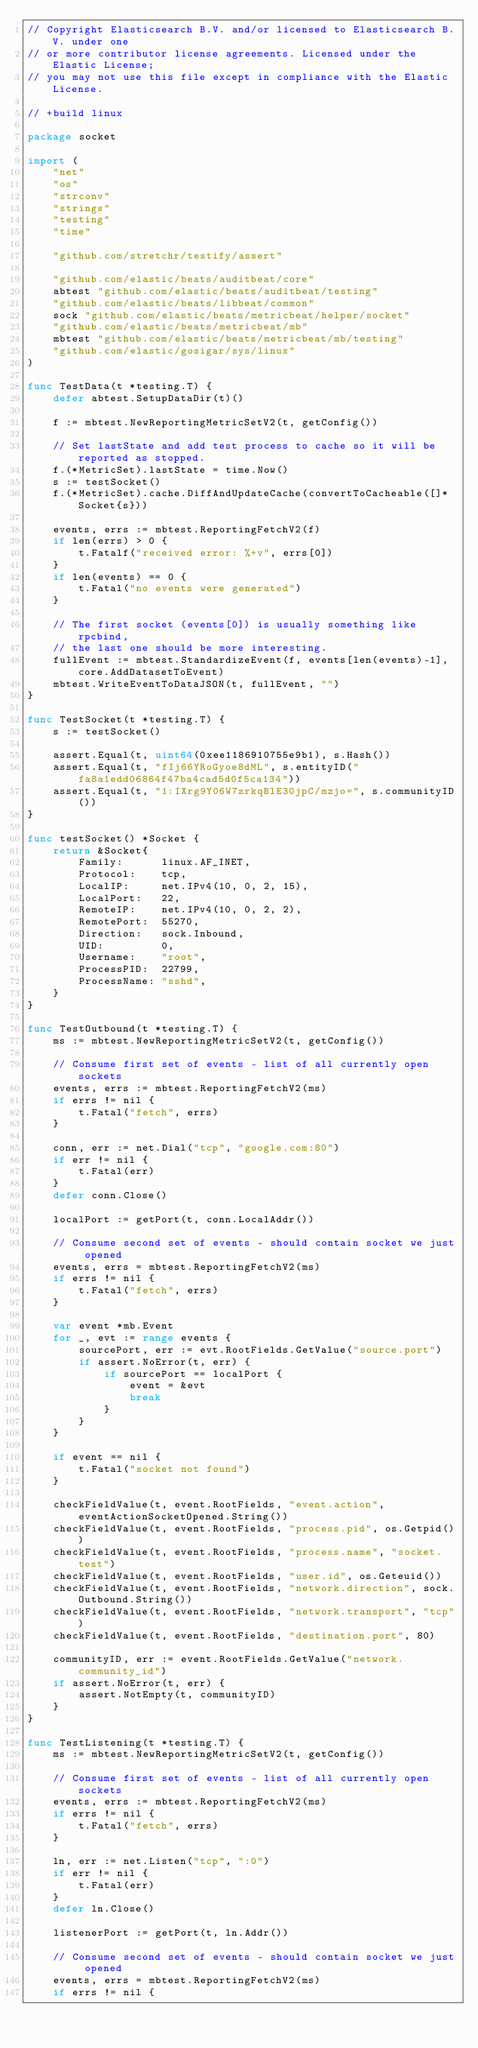<code> <loc_0><loc_0><loc_500><loc_500><_Go_>// Copyright Elasticsearch B.V. and/or licensed to Elasticsearch B.V. under one
// or more contributor license agreements. Licensed under the Elastic License;
// you may not use this file except in compliance with the Elastic License.

// +build linux

package socket

import (
	"net"
	"os"
	"strconv"
	"strings"
	"testing"
	"time"

	"github.com/stretchr/testify/assert"

	"github.com/elastic/beats/auditbeat/core"
	abtest "github.com/elastic/beats/auditbeat/testing"
	"github.com/elastic/beats/libbeat/common"
	sock "github.com/elastic/beats/metricbeat/helper/socket"
	"github.com/elastic/beats/metricbeat/mb"
	mbtest "github.com/elastic/beats/metricbeat/mb/testing"
	"github.com/elastic/gosigar/sys/linux"
)

func TestData(t *testing.T) {
	defer abtest.SetupDataDir(t)()

	f := mbtest.NewReportingMetricSetV2(t, getConfig())

	// Set lastState and add test process to cache so it will be reported as stopped.
	f.(*MetricSet).lastState = time.Now()
	s := testSocket()
	f.(*MetricSet).cache.DiffAndUpdateCache(convertToCacheable([]*Socket{s}))

	events, errs := mbtest.ReportingFetchV2(f)
	if len(errs) > 0 {
		t.Fatalf("received error: %+v", errs[0])
	}
	if len(events) == 0 {
		t.Fatal("no events were generated")
	}

	// The first socket (events[0]) is usually something like rpcbind,
	// the last one should be more interesting.
	fullEvent := mbtest.StandardizeEvent(f, events[len(events)-1], core.AddDatasetToEvent)
	mbtest.WriteEventToDataJSON(t, fullEvent, "")
}

func TestSocket(t *testing.T) {
	s := testSocket()

	assert.Equal(t, uint64(0xee1186910755e9b1), s.Hash())
	assert.Equal(t, "fIj66YRoGyoe8dML", s.entityID("fa8a1edd06864f47ba4cad5d0f5ca134"))
	assert.Equal(t, "1:IXrg9Y06W7zrkqBlE30jpC/mzjo=", s.communityID())
}

func testSocket() *Socket {
	return &Socket{
		Family:      linux.AF_INET,
		Protocol:    tcp,
		LocalIP:     net.IPv4(10, 0, 2, 15),
		LocalPort:   22,
		RemoteIP:    net.IPv4(10, 0, 2, 2),
		RemotePort:  55270,
		Direction:   sock.Inbound,
		UID:         0,
		Username:    "root",
		ProcessPID:  22799,
		ProcessName: "sshd",
	}
}

func TestOutbound(t *testing.T) {
	ms := mbtest.NewReportingMetricSetV2(t, getConfig())

	// Consume first set of events - list of all currently open sockets
	events, errs := mbtest.ReportingFetchV2(ms)
	if errs != nil {
		t.Fatal("fetch", errs)
	}

	conn, err := net.Dial("tcp", "google.com:80")
	if err != nil {
		t.Fatal(err)
	}
	defer conn.Close()

	localPort := getPort(t, conn.LocalAddr())

	// Consume second set of events - should contain socket we just opened
	events, errs = mbtest.ReportingFetchV2(ms)
	if errs != nil {
		t.Fatal("fetch", errs)
	}

	var event *mb.Event
	for _, evt := range events {
		sourcePort, err := evt.RootFields.GetValue("source.port")
		if assert.NoError(t, err) {
			if sourcePort == localPort {
				event = &evt
				break
			}
		}
	}

	if event == nil {
		t.Fatal("socket not found")
	}

	checkFieldValue(t, event.RootFields, "event.action", eventActionSocketOpened.String())
	checkFieldValue(t, event.RootFields, "process.pid", os.Getpid())
	checkFieldValue(t, event.RootFields, "process.name", "socket.test")
	checkFieldValue(t, event.RootFields, "user.id", os.Geteuid())
	checkFieldValue(t, event.RootFields, "network.direction", sock.Outbound.String())
	checkFieldValue(t, event.RootFields, "network.transport", "tcp")
	checkFieldValue(t, event.RootFields, "destination.port", 80)

	communityID, err := event.RootFields.GetValue("network.community_id")
	if assert.NoError(t, err) {
		assert.NotEmpty(t, communityID)
	}
}

func TestListening(t *testing.T) {
	ms := mbtest.NewReportingMetricSetV2(t, getConfig())

	// Consume first set of events - list of all currently open sockets
	events, errs := mbtest.ReportingFetchV2(ms)
	if errs != nil {
		t.Fatal("fetch", errs)
	}

	ln, err := net.Listen("tcp", ":0")
	if err != nil {
		t.Fatal(err)
	}
	defer ln.Close()

	listenerPort := getPort(t, ln.Addr())

	// Consume second set of events - should contain socket we just opened
	events, errs = mbtest.ReportingFetchV2(ms)
	if errs != nil {</code> 